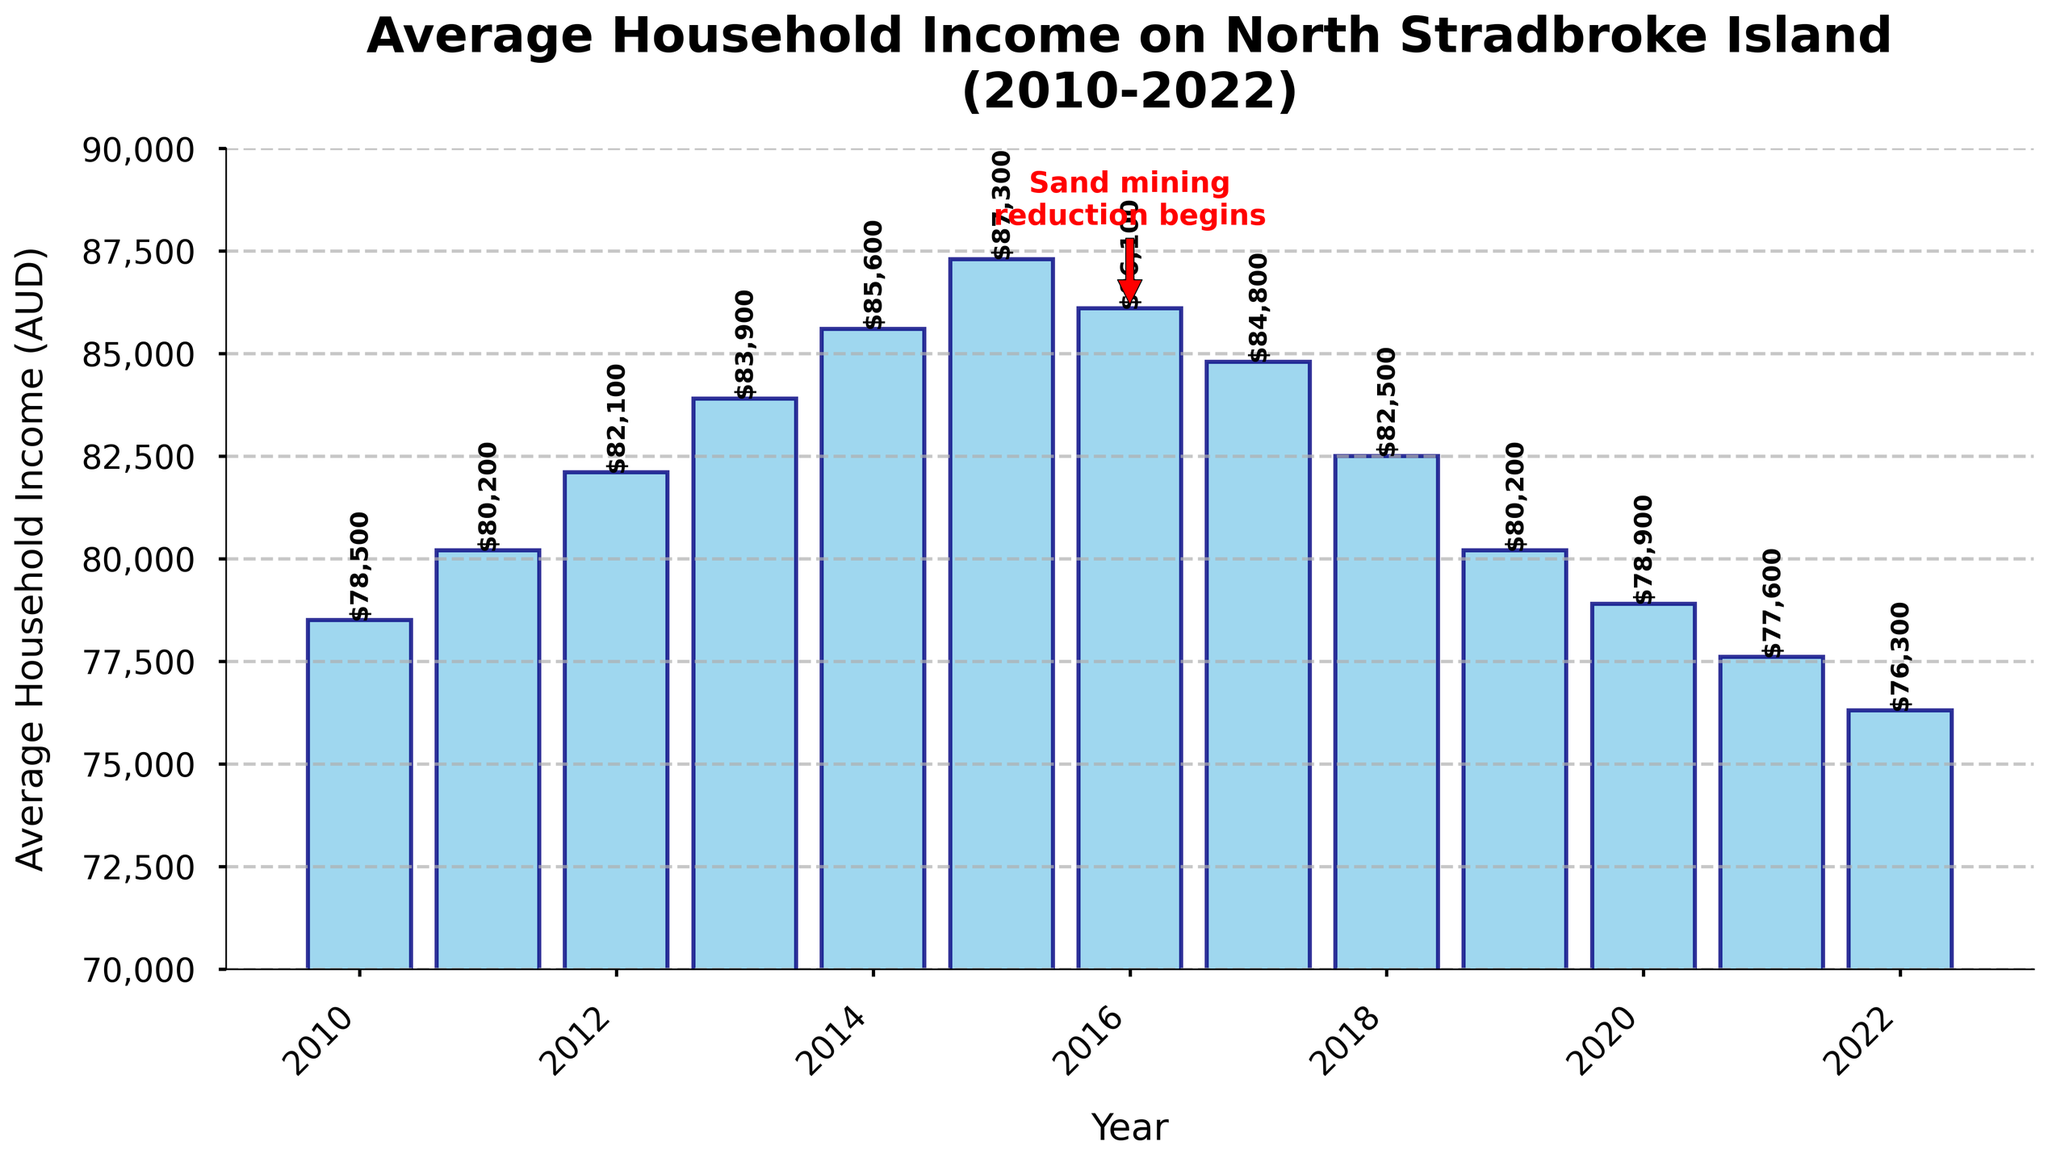What's the average household income before and after the sand mining reduction began in 2016? To find the average income before sand mining reduction, add the incomes from 2010 to 2015 and divide by the number of years: (78500 + 80200 + 82100 + 83900 + 85600 + 87300) / 6 = 82,933.33 AUD. For the period after 2016 to 2022, perform the same operation: (86100 + 84800 + 82500 + 80200 + 78900 + 77600 + 76300) / 7 = 80,057.14 AUD
Answer: 82,933.33 AUD and 80,057.14 AUD How did the average household income change from 2015 to 2016, the year sand mining reduction began? Look at the bar heights for 2015 and 2016 to find the difference: 87300 - 86100 = 1200 AUD. The income decreased by 1200 AUD from 2015 to 2016.
Answer: Decreased by 1200 AUD Between which years was the largest drop in average household income observed, and what was the amount? Compare the differences between each consecutive year's incomes. The largest drop is between 2015 and 2016, with a decrease of 1200 AUD.
Answer: 2015 to 2016, 1200 AUD What is the trend in average household income from 2010 to 2015 compared to 2016 to 2022? From 2010 to 2015, the income shows an increasing trend, peaking in 2015. From 2016 to 2022, the income generally decreases each year.
Answer: Increasing trend from 2010 to 2015, decreasing trend from 2016 to 2022 What was the highest average household income recorded, and in which year did it occur? Identify the tallest bar to see that the highest income is 87300 AUD in 2015.
Answer: 87300 AUD, in 2015 Which year marked the beginning of a consistent decline in average household income? Identify the first year after 2015 when the income consistently decreases each subsequent year. It starts from 2016.
Answer: 2016 What is the difference in average household income between 2010 and 2022? Subtract the income for 2010 from the income for 2022: 76300 - 78500 = -2200 AUD, representing a decrease.
Answer: Decreased by 2200 AUD How does the average household income in 2022 compare with that in 2016? Identify the income values for 2016 and 2022 and compare them. Income in 2016 is 86100 AUD, and in 2022 it is 76300 AUD. Hence, it decreased by 9800 AUD.
Answer: Decreased by 9800 AUD What annotation is highlighted on the graph, and what does it signify? The annotation marked with an arrow and text "Sand mining\nreduction begins" indicates the beginning of the sand mining reduction period in 2016 at an income of 86100 AUD.
Answer: Sand mining reduction begins in 2016 at 86100 AUD 